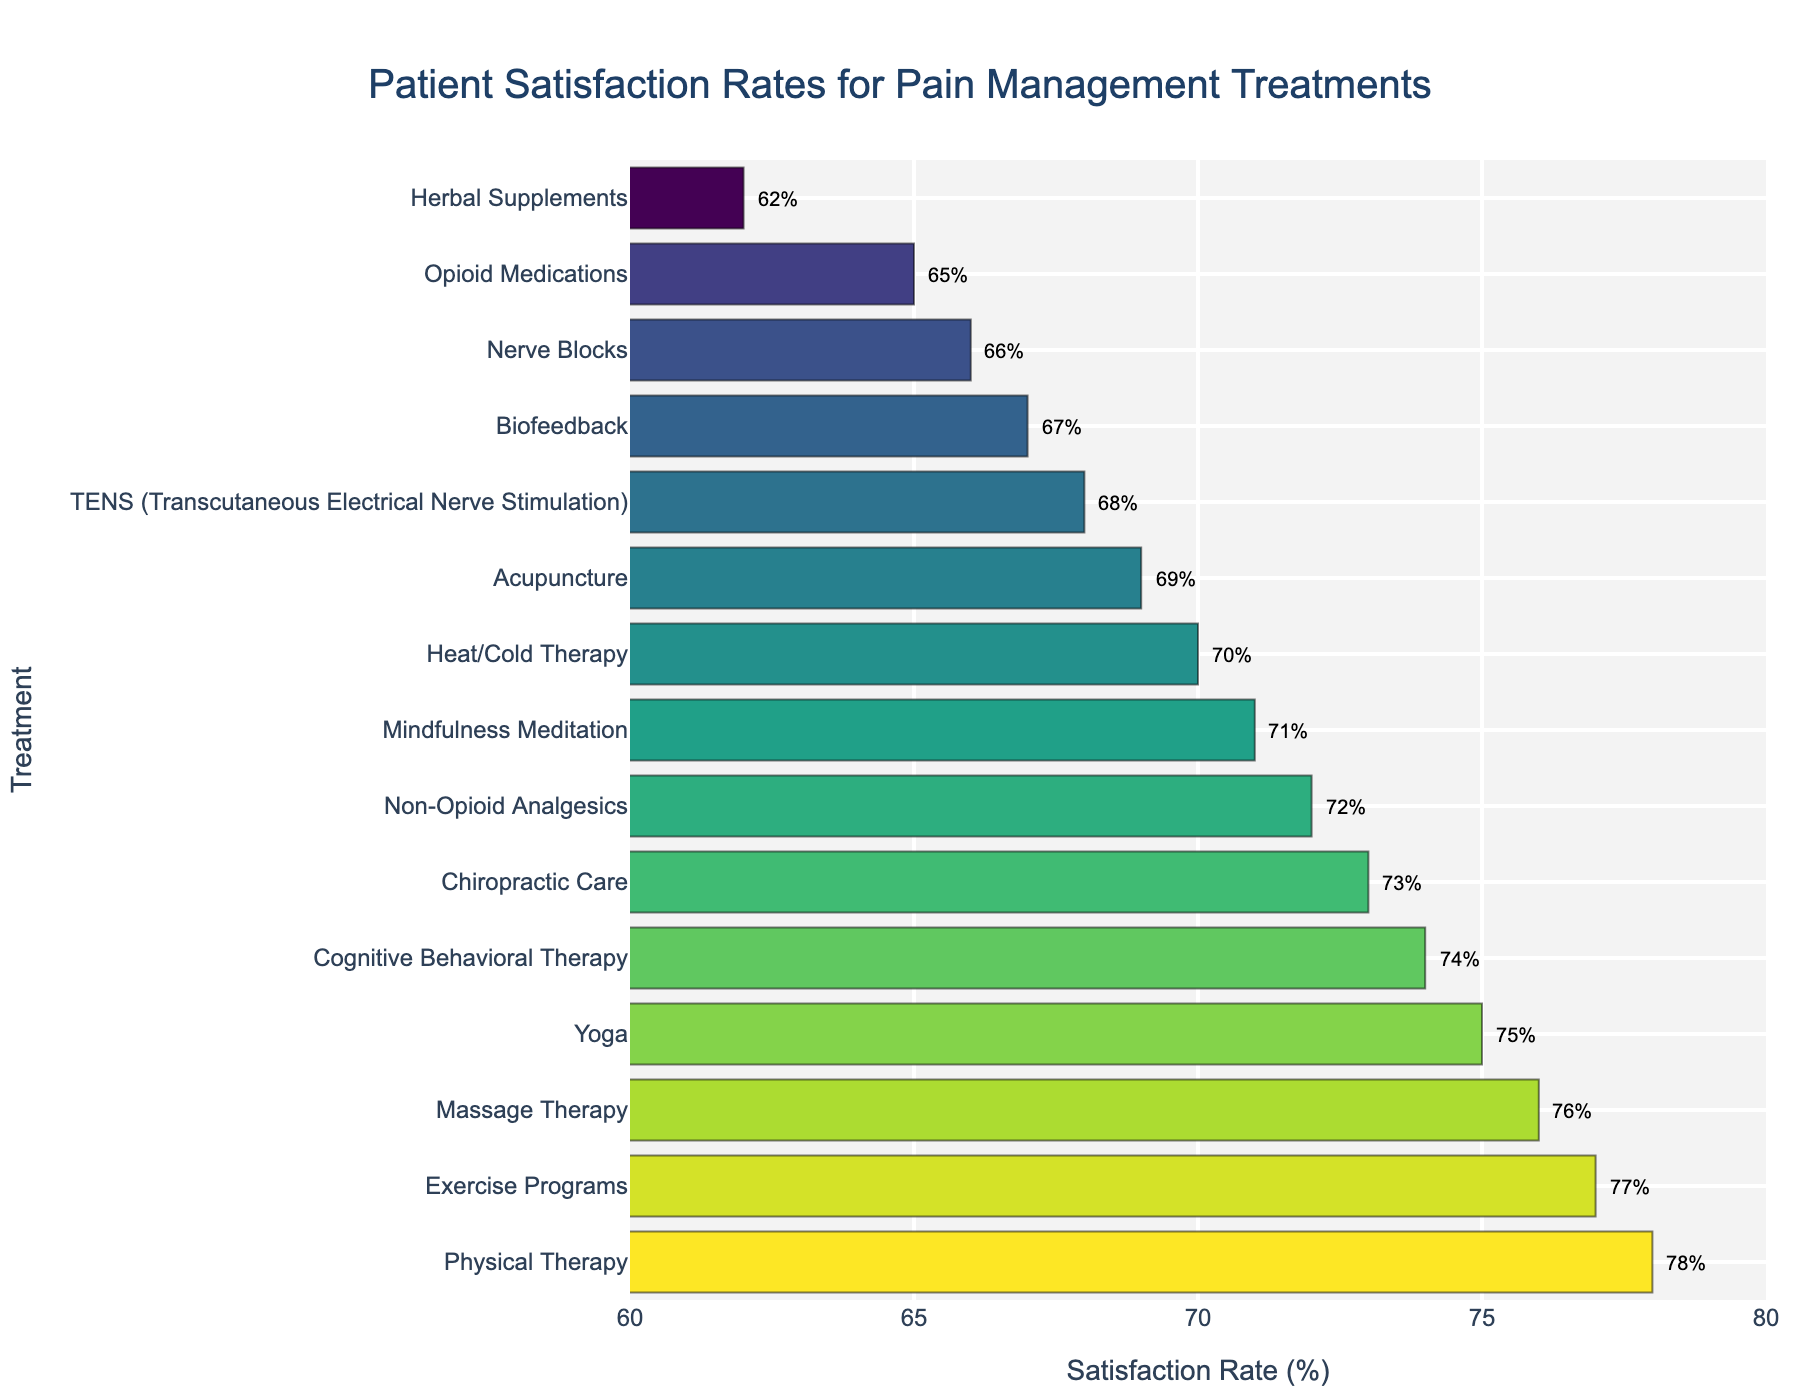What's the treatment with the highest patient satisfaction rate? By looking at the top of the bar chart, the treatment with the highest satisfaction rate is shown visually.
Answer: Physical Therapy Which treatment has the lowest satisfaction rate, and what is the percentage? By identifying the smallest bar in the chart, the treatment with the lowest satisfaction rate and its percentage can be determined.
Answer: Herbal Supplements, 62% How much higher is the satisfaction rate of Cognitive Behavioral Therapy compared to Opioid Medications? Locate the bars for Cognitive Behavioral Therapy and Opioid Medications, subtract the satisfaction rate of Opioid Medications from Cognitive Behavioral Therapy. (74% - 65%)
Answer: 9% Which treatments have a satisfaction rate above 70%? Identify and list all bars with a satisfaction rate greater than 70%.
Answer: Non-Opioid Analgesics, Physical Therapy, Acupuncture, Cognitive Behavioral Therapy, Massage Therapy, Mindfulness Meditation, Chiropractic Care, Exercise Programs, Yoga How does the satisfaction rate of Physical Therapy compare visually to that of Exercise Programs? Compare the lengths of the bars for both treatments; they are very close in length, representing their similar percentages.
Answer: Physical Therapy is slightly higher What is the average satisfaction rate of the three treatments with the highest rates? Take the satisfaction rates of the top three treatments (Physical Therapy, Exercise Programs, and Massage Therapy), sum them up, and divide by 3. (78% + 77% + 76%) / 3
Answer: 77% Which treatments have a satisfaction rate between 65% and 70%, inclusive? Identify and list all bars whose satisfaction rate falls between 65% and 70%, inclusive.
Answer: Opioid Medications, Acupuncture, TENS, Heat/Cold Therapy, Nerve Blocks, Biofeedback How many treatments have a satisfaction rate below 70%? Count the number of bars with satisfaction rates less than 70%.
Answer: 6 What visual pattern do you notice with the satisfaction rates in the chart? The colors and lengths of bars gradually change, indicating a spectrum of satisfaction rates from lower to higher values.
Answer: Colors and lengths show a gradient 